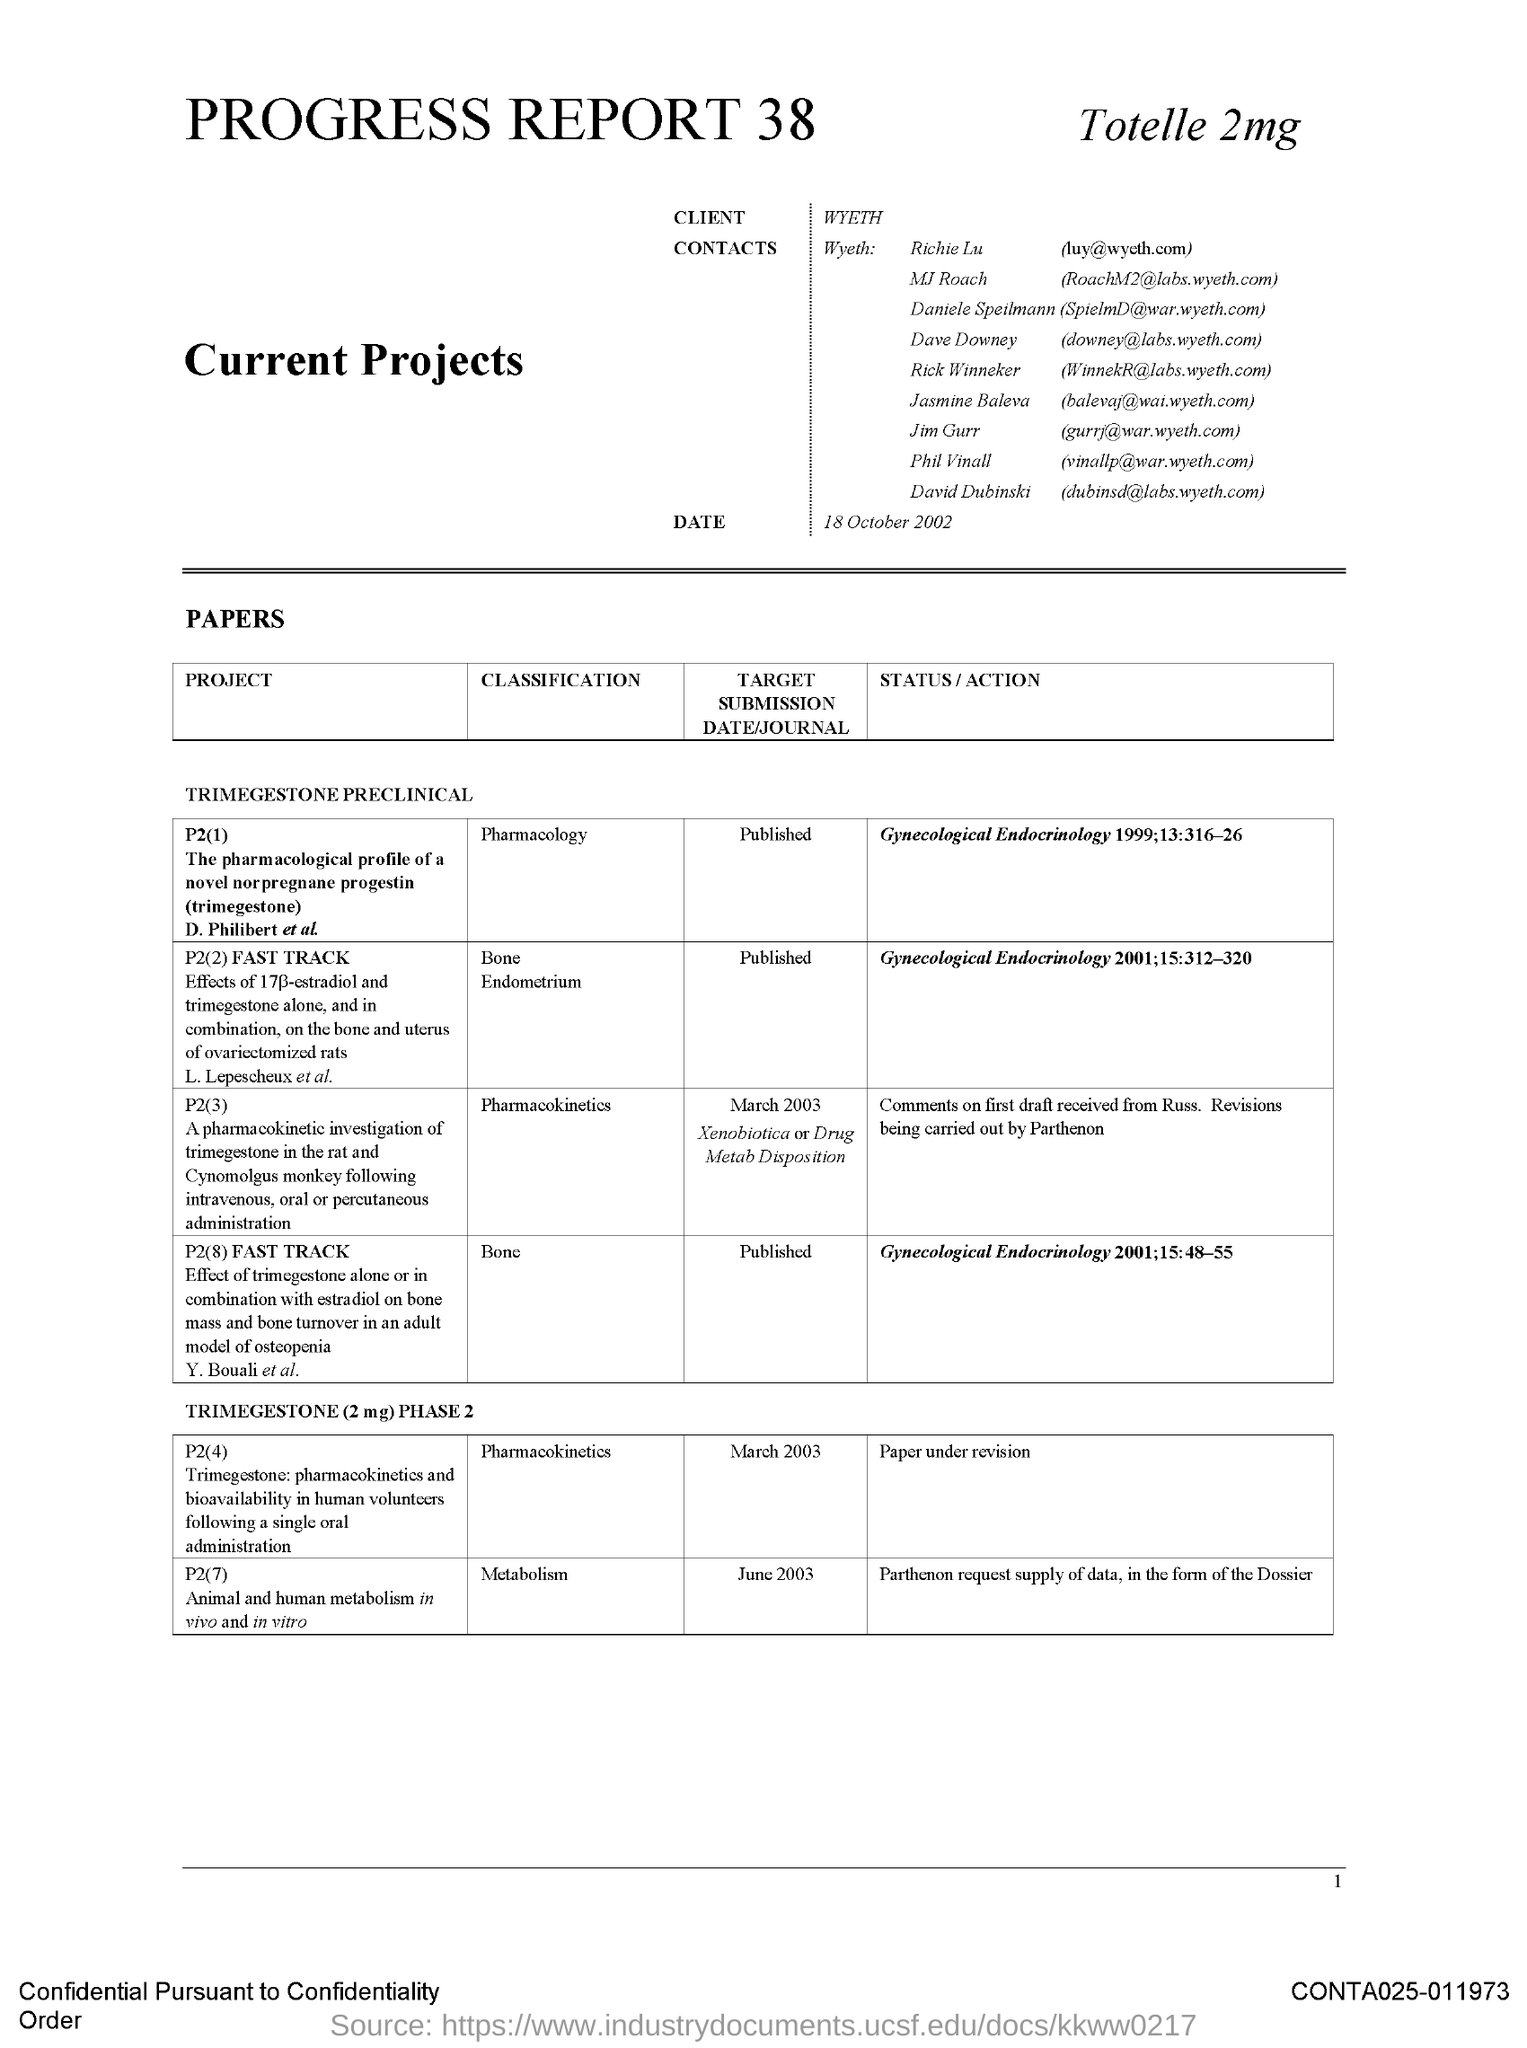Indicate a few pertinent items in this graphic. The classification of project P2(2) is Bone Endometrium. 